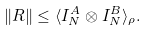Convert formula to latex. <formula><loc_0><loc_0><loc_500><loc_500>\| R \| \leq \langle I _ { N } ^ { A } \otimes I _ { N } ^ { B } \rangle _ { \rho } .</formula> 